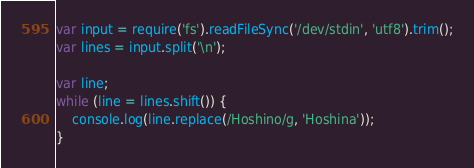Convert code to text. <code><loc_0><loc_0><loc_500><loc_500><_JavaScript_>var input = require('fs').readFileSync('/dev/stdin', 'utf8').trim();
var lines = input.split('\n');

var line;
while (line = lines.shift()) {
    console.log(line.replace(/Hoshino/g, 'Hoshina'));
}</code> 